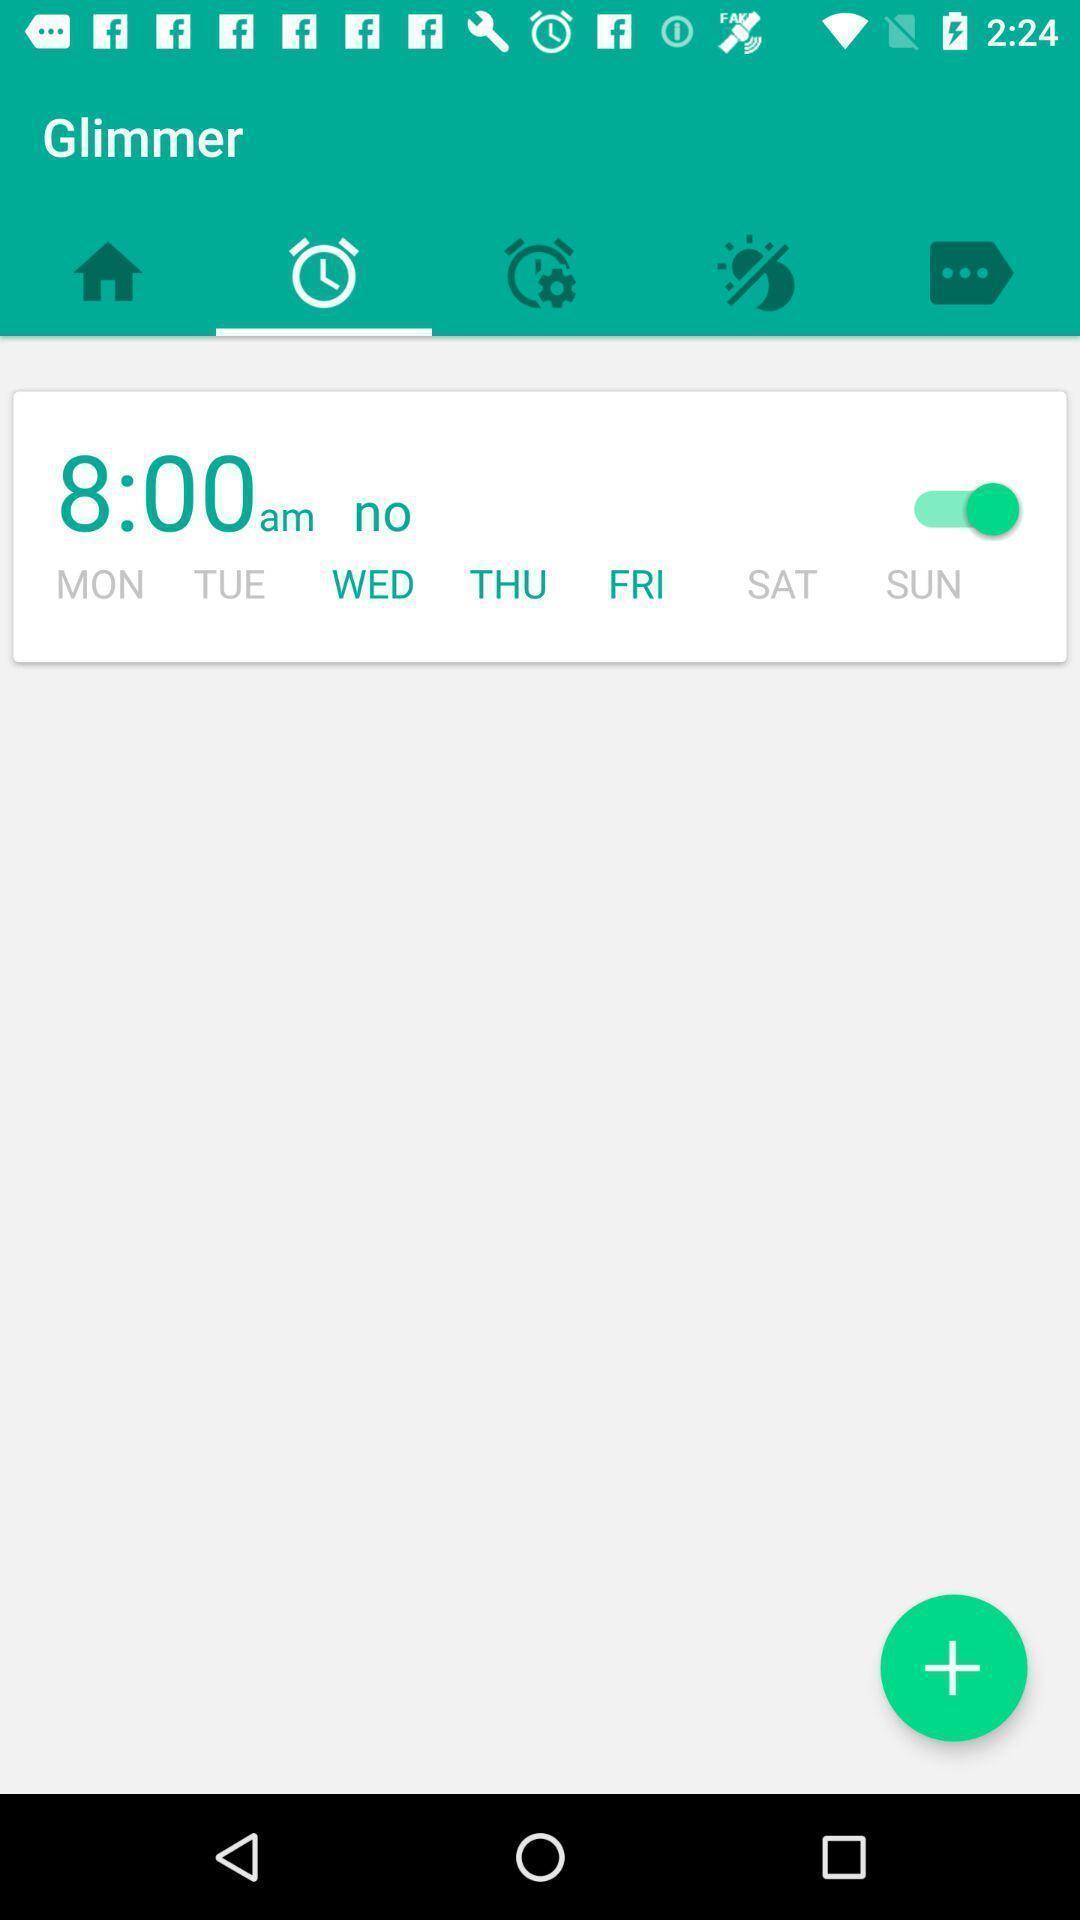Provide a textual representation of this image. Page displaying various options in alarm application. 